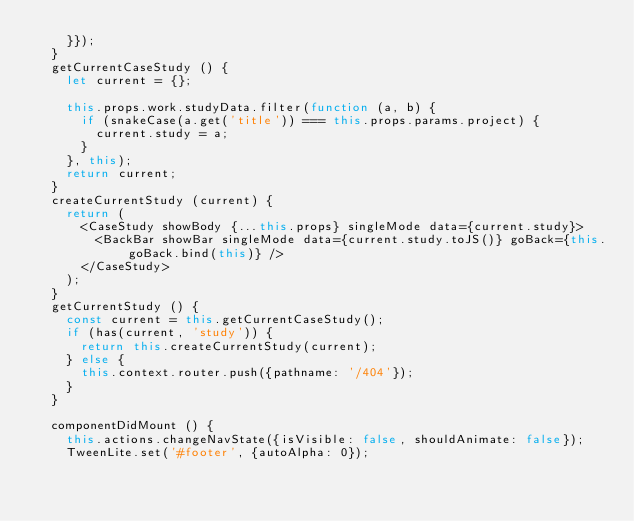Convert code to text. <code><loc_0><loc_0><loc_500><loc_500><_JavaScript_>    }});
  }
  getCurrentCaseStudy () {
    let current = {};

    this.props.work.studyData.filter(function (a, b) {
      if (snakeCase(a.get('title')) === this.props.params.project) {
        current.study = a;
      }
    }, this);
    return current;
  }
  createCurrentStudy (current) {
    return (
      <CaseStudy showBody {...this.props} singleMode data={current.study}>
        <BackBar showBar singleMode data={current.study.toJS()} goBack={this.goBack.bind(this)} />
      </CaseStudy>
    );
  }
  getCurrentStudy () {
    const current = this.getCurrentCaseStudy();
    if (has(current, 'study')) {
      return this.createCurrentStudy(current);
    } else {
      this.context.router.push({pathname: '/404'});
    }
  }

  componentDidMount () {
    this.actions.changeNavState({isVisible: false, shouldAnimate: false});
    TweenLite.set('#footer', {autoAlpha: 0});</code> 